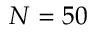<formula> <loc_0><loc_0><loc_500><loc_500>N = 5 0</formula> 